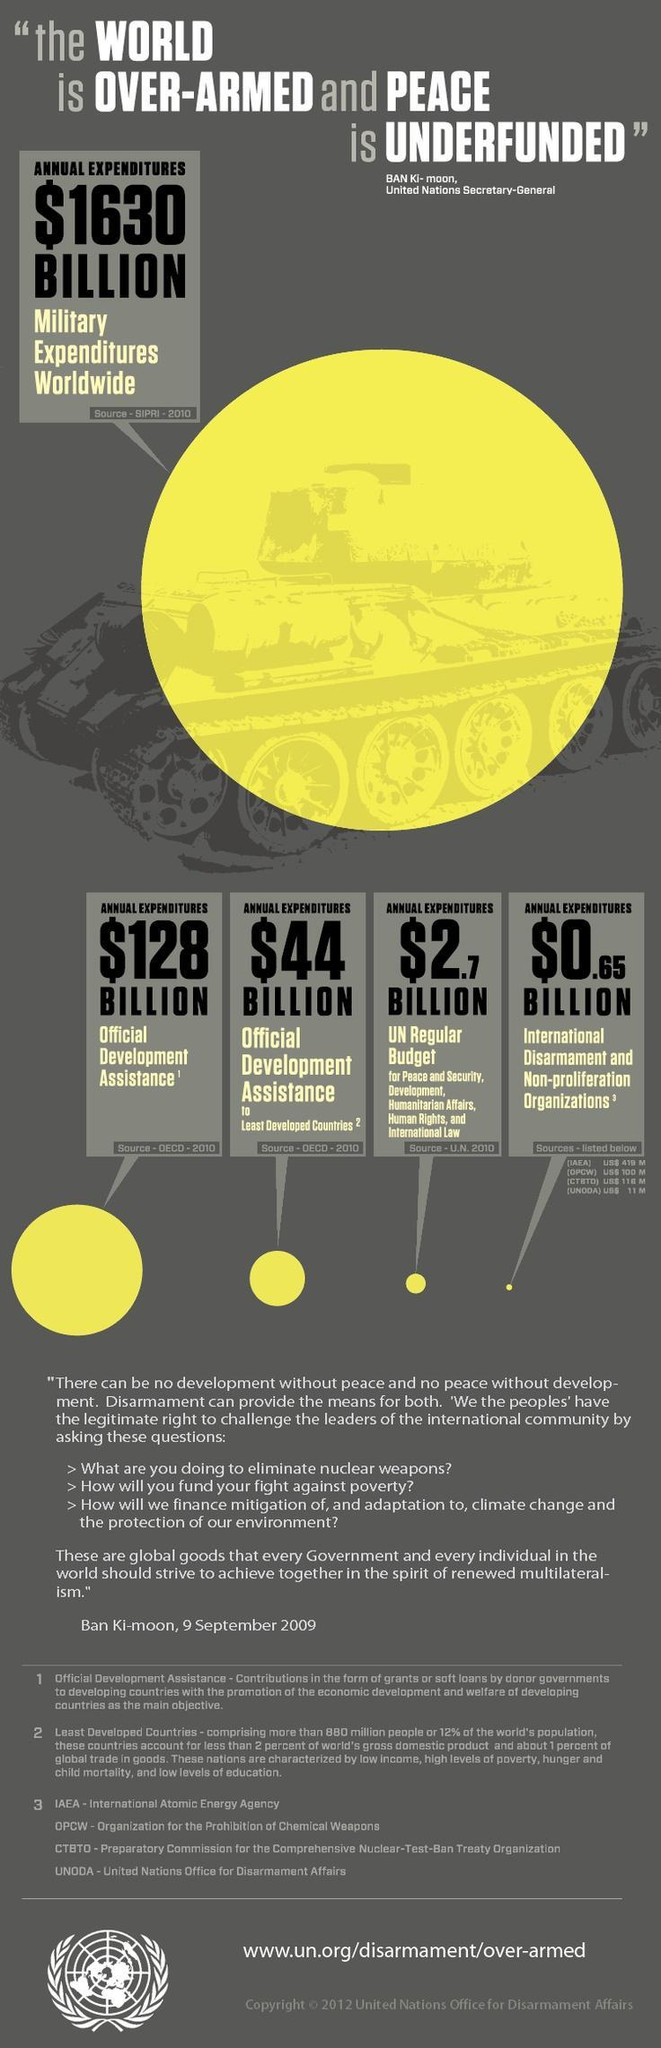What is the annual expenditure for official development assistance to least developed countries?
Answer the question with a short phrase. $44 BILLION What is the annual expenditure for International Disarmament & Non-proliferation Organizations? $0.65 BILLION 